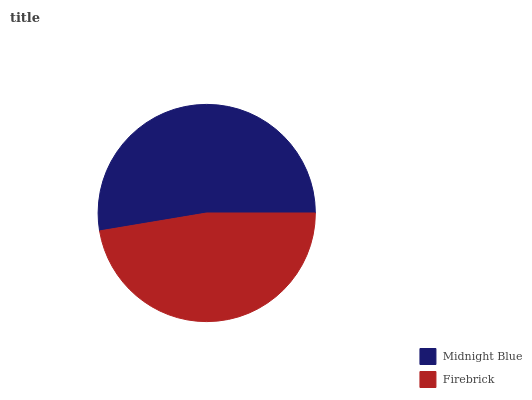Is Firebrick the minimum?
Answer yes or no. Yes. Is Midnight Blue the maximum?
Answer yes or no. Yes. Is Firebrick the maximum?
Answer yes or no. No. Is Midnight Blue greater than Firebrick?
Answer yes or no. Yes. Is Firebrick less than Midnight Blue?
Answer yes or no. Yes. Is Firebrick greater than Midnight Blue?
Answer yes or no. No. Is Midnight Blue less than Firebrick?
Answer yes or no. No. Is Midnight Blue the high median?
Answer yes or no. Yes. Is Firebrick the low median?
Answer yes or no. Yes. Is Firebrick the high median?
Answer yes or no. No. Is Midnight Blue the low median?
Answer yes or no. No. 